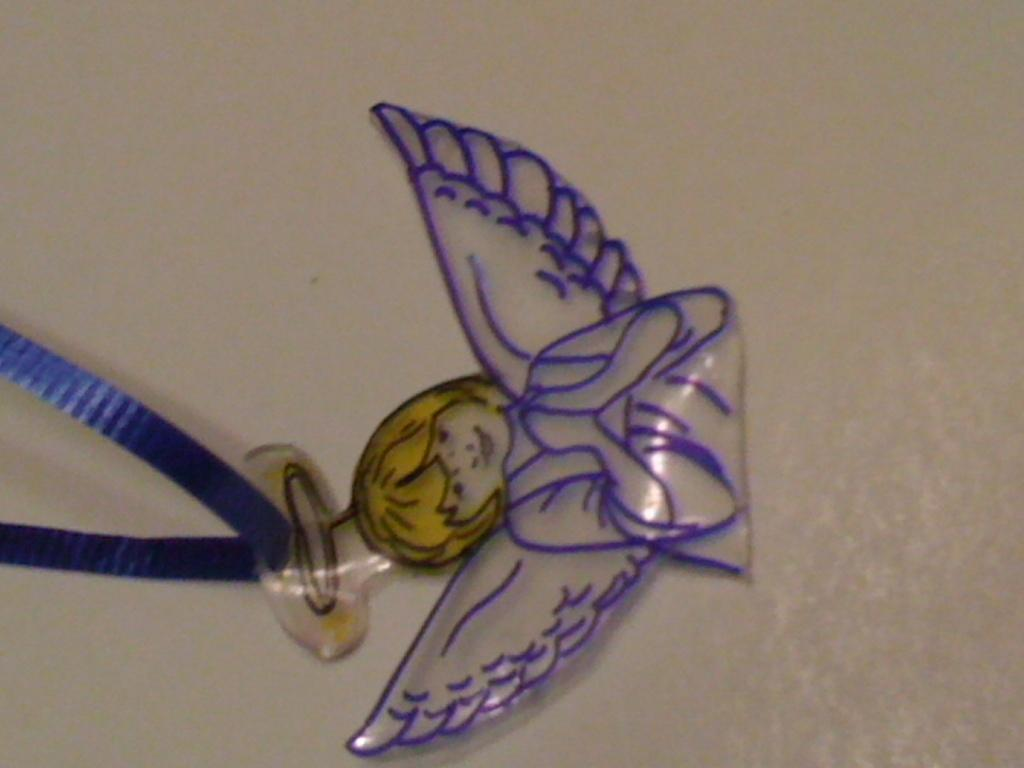What type of toy is present in the image? There is a toy of an angel in the image. Is the toy of an angel connected to any other object in the image? Yes, the toy of an angel is attached to a tag. What design is featured on the net in the image? There is no net present in the image; it only contains a toy of an angel attached to a tag. 